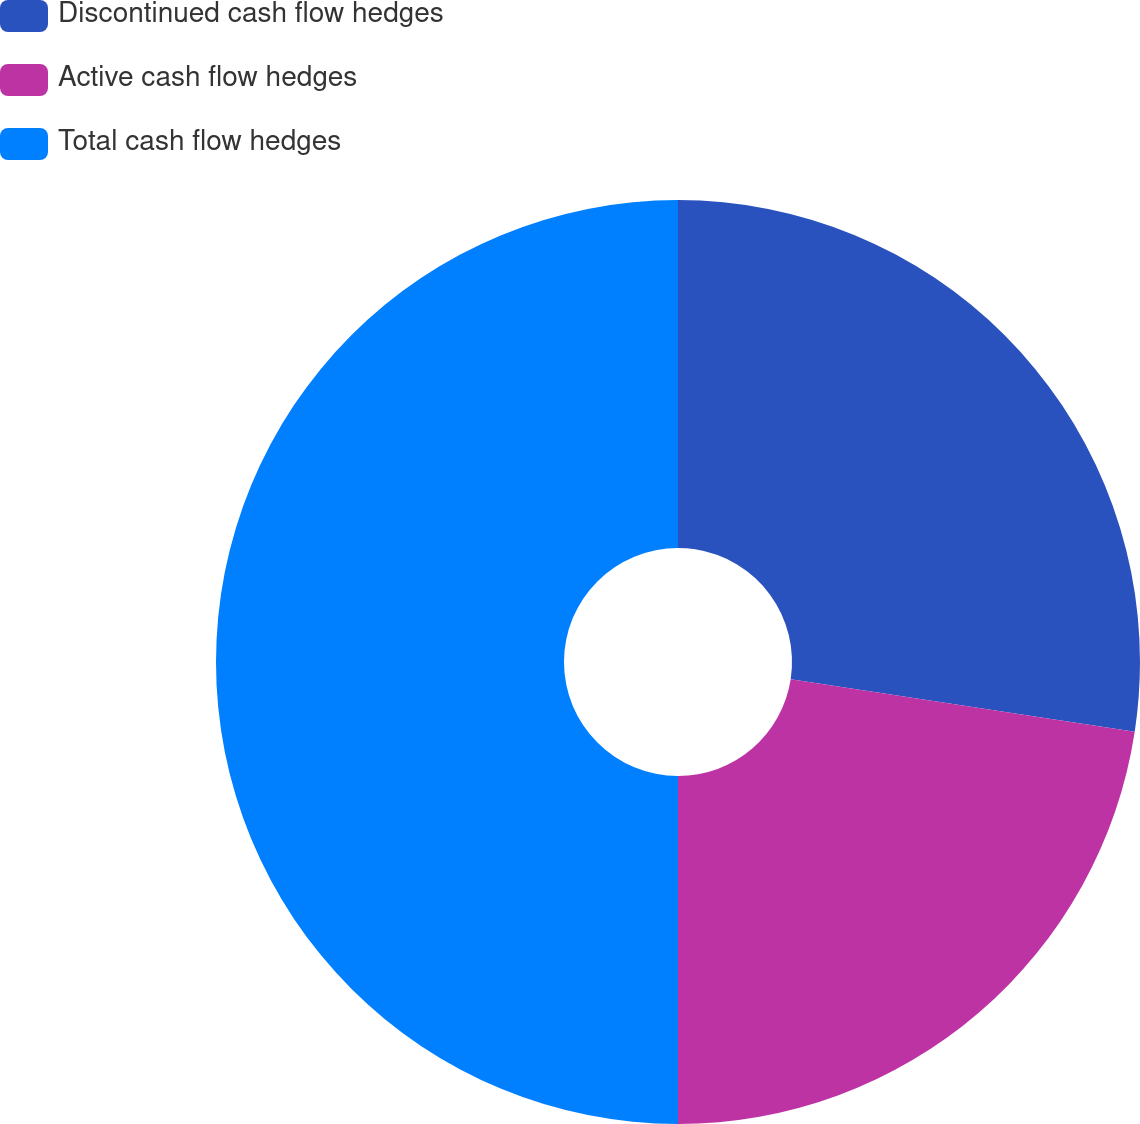Convert chart. <chart><loc_0><loc_0><loc_500><loc_500><pie_chart><fcel>Discontinued cash flow hedges<fcel>Active cash flow hedges<fcel>Total cash flow hedges<nl><fcel>27.41%<fcel>22.59%<fcel>50.0%<nl></chart> 